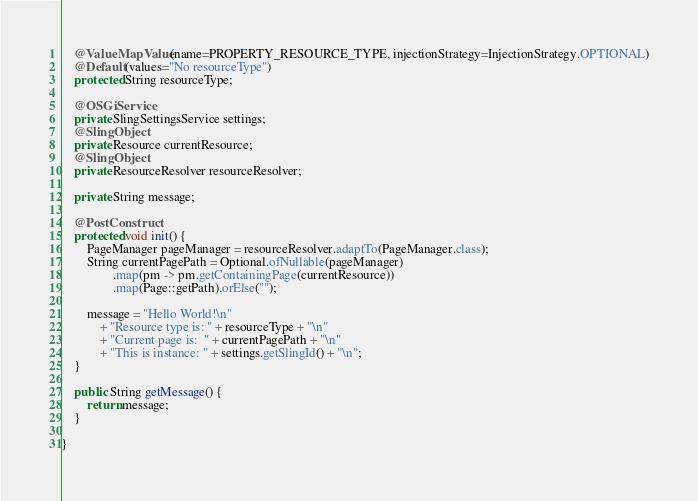<code> <loc_0><loc_0><loc_500><loc_500><_Java_>
    @ValueMapValue(name=PROPERTY_RESOURCE_TYPE, injectionStrategy=InjectionStrategy.OPTIONAL)
    @Default(values="No resourceType")
    protected String resourceType;

    @OSGiService
    private SlingSettingsService settings;
    @SlingObject
    private Resource currentResource;
    @SlingObject
    private ResourceResolver resourceResolver;

    private String message;

    @PostConstruct
    protected void init() {
        PageManager pageManager = resourceResolver.adaptTo(PageManager.class);
        String currentPagePath = Optional.ofNullable(pageManager)
                .map(pm -> pm.getContainingPage(currentResource))
                .map(Page::getPath).orElse("");

        message = "Hello World!\n"
            + "Resource type is: " + resourceType + "\n"
            + "Current page is:  " + currentPagePath + "\n"
            + "This is instance: " + settings.getSlingId() + "\n";
    }

    public String getMessage() {
        return message;
    }

}
</code> 